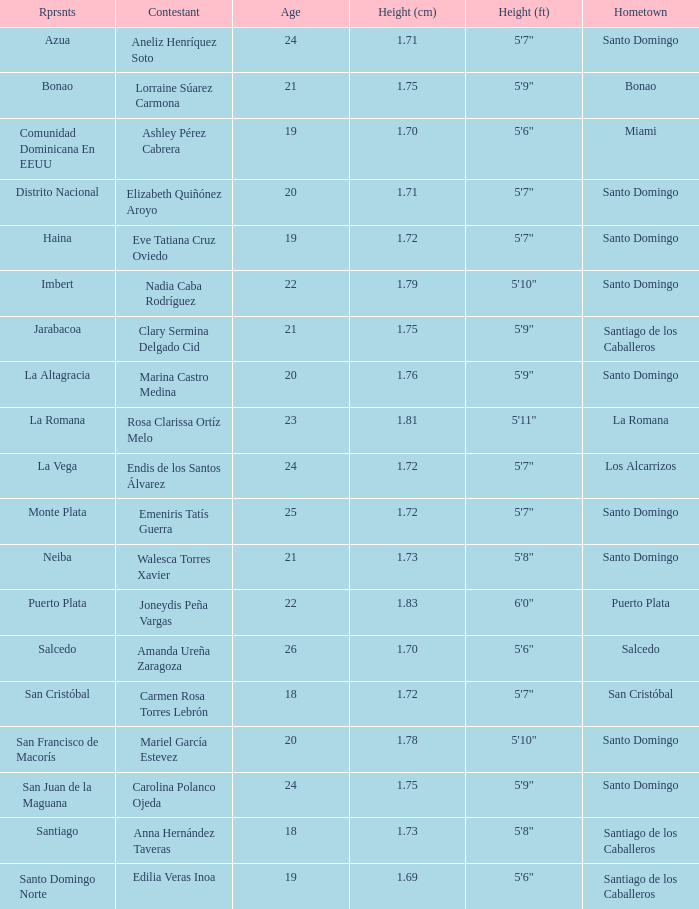Name the least age for distrito nacional 20.0. 